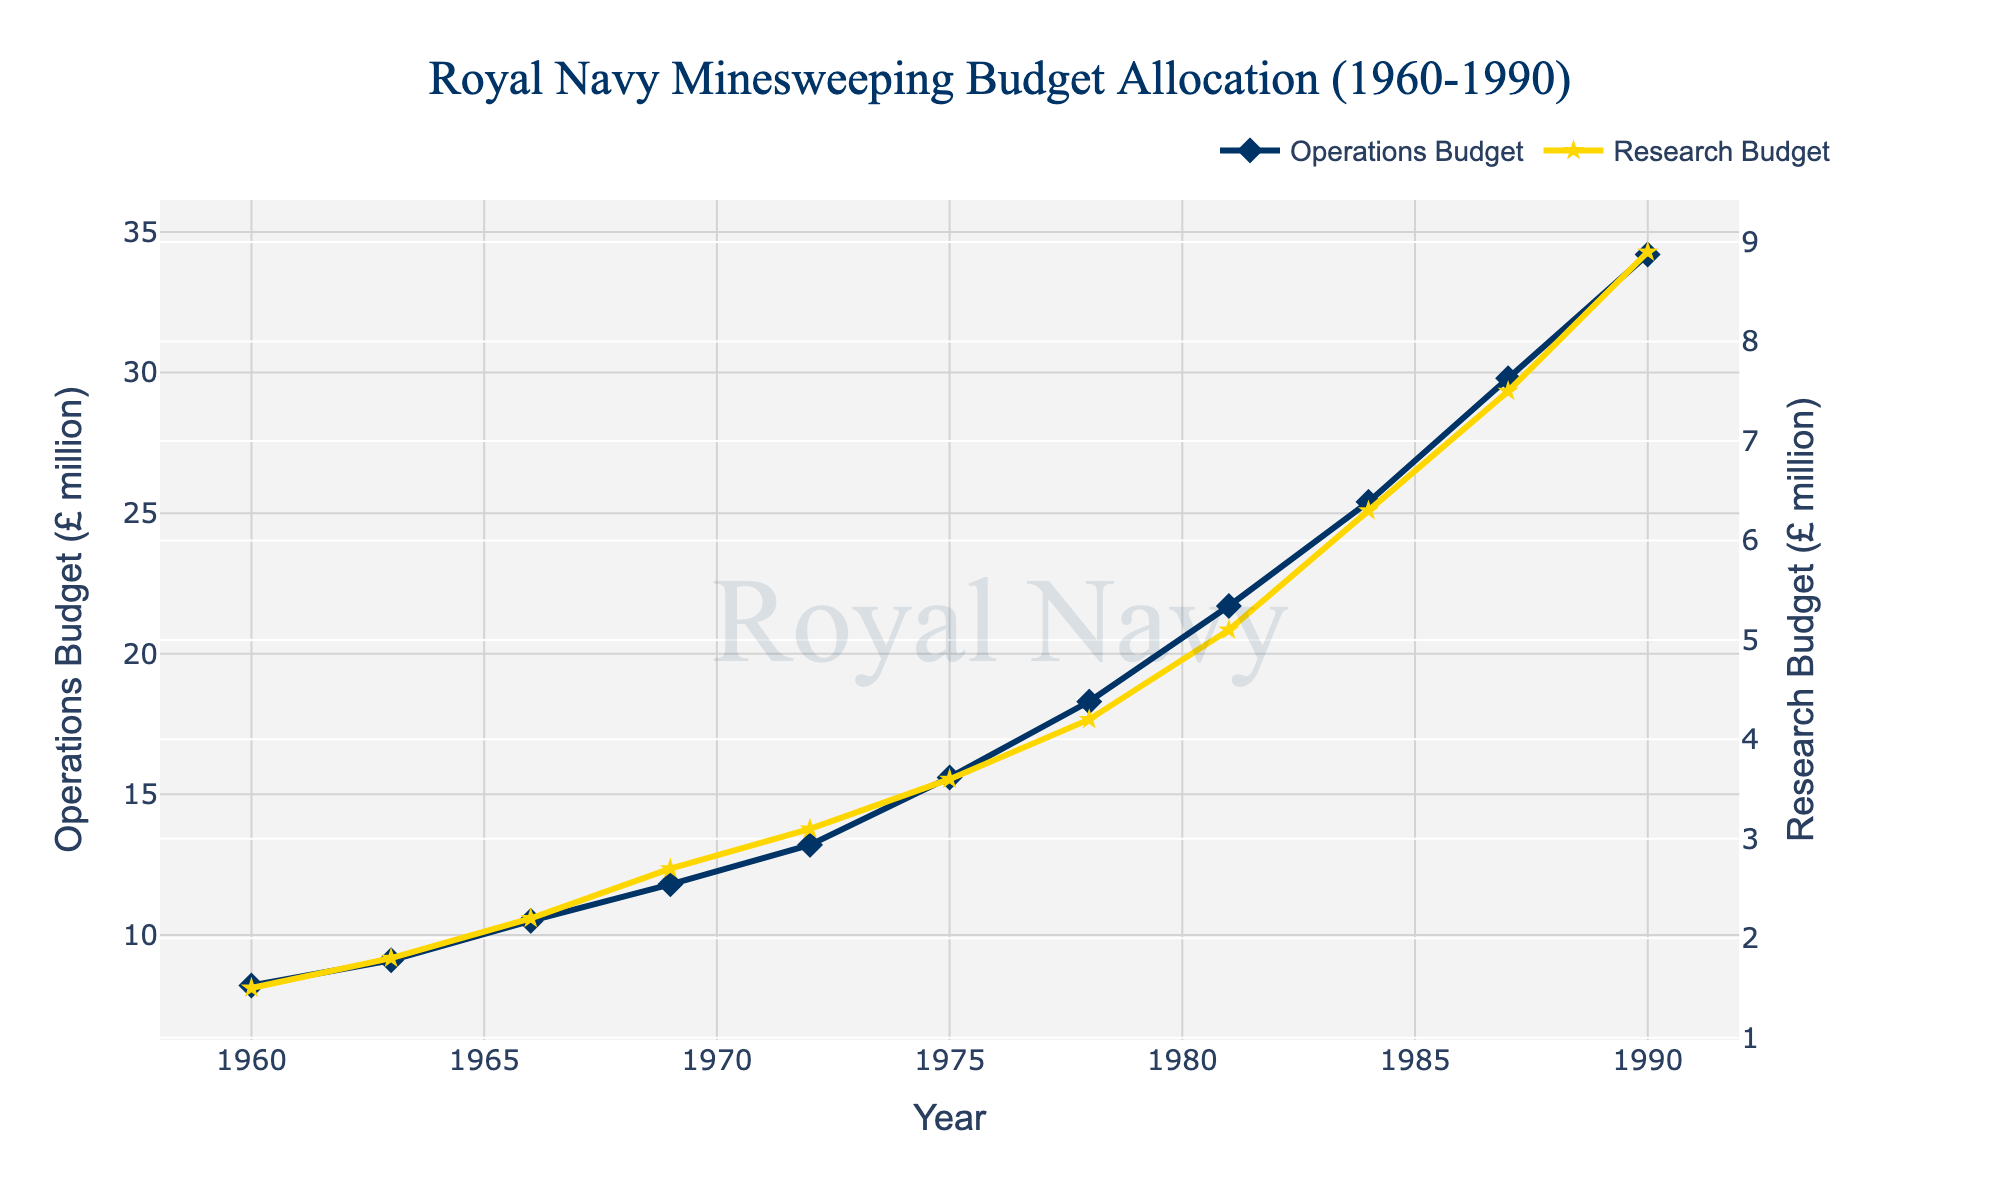How does the budget for minesweeping operations in 1981 compare to that in 1984? In 1981, the budget for minesweeping operations is £21.7 million. In 1984, it is £25.4 million, an increase of £3.7 million from 1981.
Answer: £3.7 million Between which two years is the largest increase in minesweeping research budget observed? Checking the yearly increments for the research budget: 1960-1963 (£1.5 to £1.8, +£0.3), 1963-1966 (+£0.4), 1966-1969 (+£0.5), 1969-1972 (+£0.4), 1972-1975 (+£0.5), 1975-1978 (+£0.6), 1978-1981 (+£0.9), 1981-1984 (+£1.2), 1984-1987 (+£1.2), 1987-1990 (+£1.4). The largest increase is from 1987 to 1990.
Answer: 1987 to 1990 What is the average minesweeping operations budget over the period 1960-1990? The budgets are £8.2, £9.1, £10.5, £11.8, £13.2, £15.6, £18.3, £21.7, £25.4, £29.8, £34.2. Sum these values: £8.2 + £9.1 + £10.5 + £11.8 + £13.2 + £15.6 + £18.3 + £21.7 + £25.4 + £29.8 + £34.2 = £197.8 million. Average = £197.8 million / 11 ≈ £18 million.
Answer: £18 million Which had a higher percentage increase from 1960 to 1990: operations budget or research budget? The operations budget increased from £8.2 million to £34.2 million. Percentage increase: ((£34.2 - £8.2) / £8.2) × 100 ≈ 317%. The research budget rose from £1.5 million to £8.9 million. Percentage increase: ((£8.9 - £1.5) / £1.5) × 100 ≈ 493%. The research budget had a higher percentage increase.
Answer: Research budget Which year saw the highest combined total of operations and research budgets? Calculate the combined totals for each year: 1960 (£8.2 + £1.5 = £9.7 million), 1963 (£9.1 + £1.8), 1966 (£10.5 + £2.2), 1969 (£11.8 + £2.7), 1972 (£13.2 + £3.1), 1975 (£15.6 + £3.6), 1978 (£18.3 + £4.2), 1981 (£21.7 + £5.1), 1984 (£25.4 + £6.3), 1987 (£29.8 + £7.5), 1990 (£34.2 + £8.9 = £43.1 million). The highest combined total is in 1990.
Answer: 1990 During which decade did the research budget see the most rapid growth? The increments in the research budget are: 1960s (from £1.5 to £2.7), 1970s (from £3.1 to £4.2), 1980s (from £5.1 to £8.9). The most significant growth is from 1980 to 1990 where the increase is from £5.1 to £8.9.
Answer: 1980s By how much did the operations budget exceed the research budget in 1978? In 1978, the operations budget is £18.3 million and the research budget is £4.2 million. The difference is £18.3 - £4.2 = £14.1 million.
Answer: £14.1 million What trend can be observed in the ratio of operations to research budget from 1960 to 1990? In 1960, the ratio is £8.2/£1.5 ≈ 5.47. In 1990, the ratio is £34.2/£8.9 ≈ 3.84. The ratio consistently decreases over the years, indicating that the research budget grew at a faster relative rate than the operations budget.
Answer: Decreasing What is the combined budget for minesweeping operations and research in 1984? The operations budget in 1984 is £25.4 million, and the research budget is £6.3 million. The combined budget is £25.4 + £6.3 = £31.7 million.
Answer: £31.7 million 